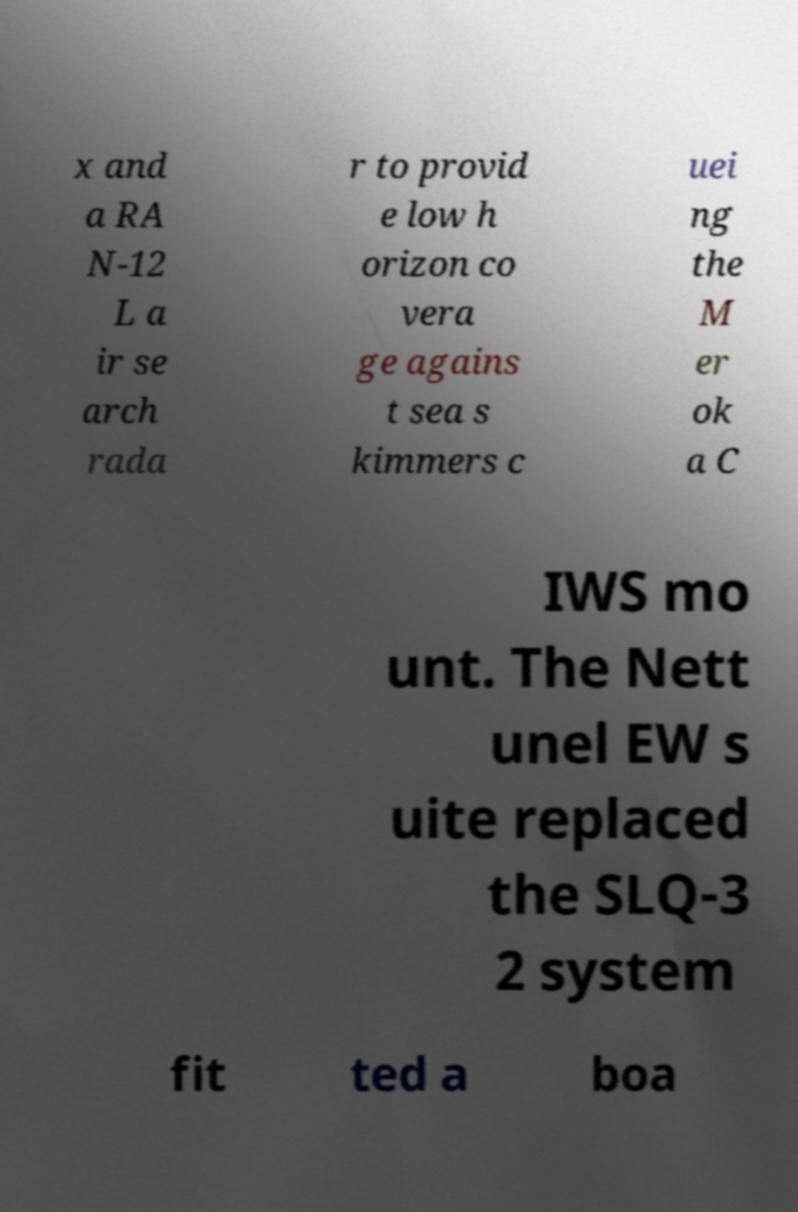I need the written content from this picture converted into text. Can you do that? x and a RA N-12 L a ir se arch rada r to provid e low h orizon co vera ge agains t sea s kimmers c uei ng the M er ok a C IWS mo unt. The Nett unel EW s uite replaced the SLQ-3 2 system fit ted a boa 